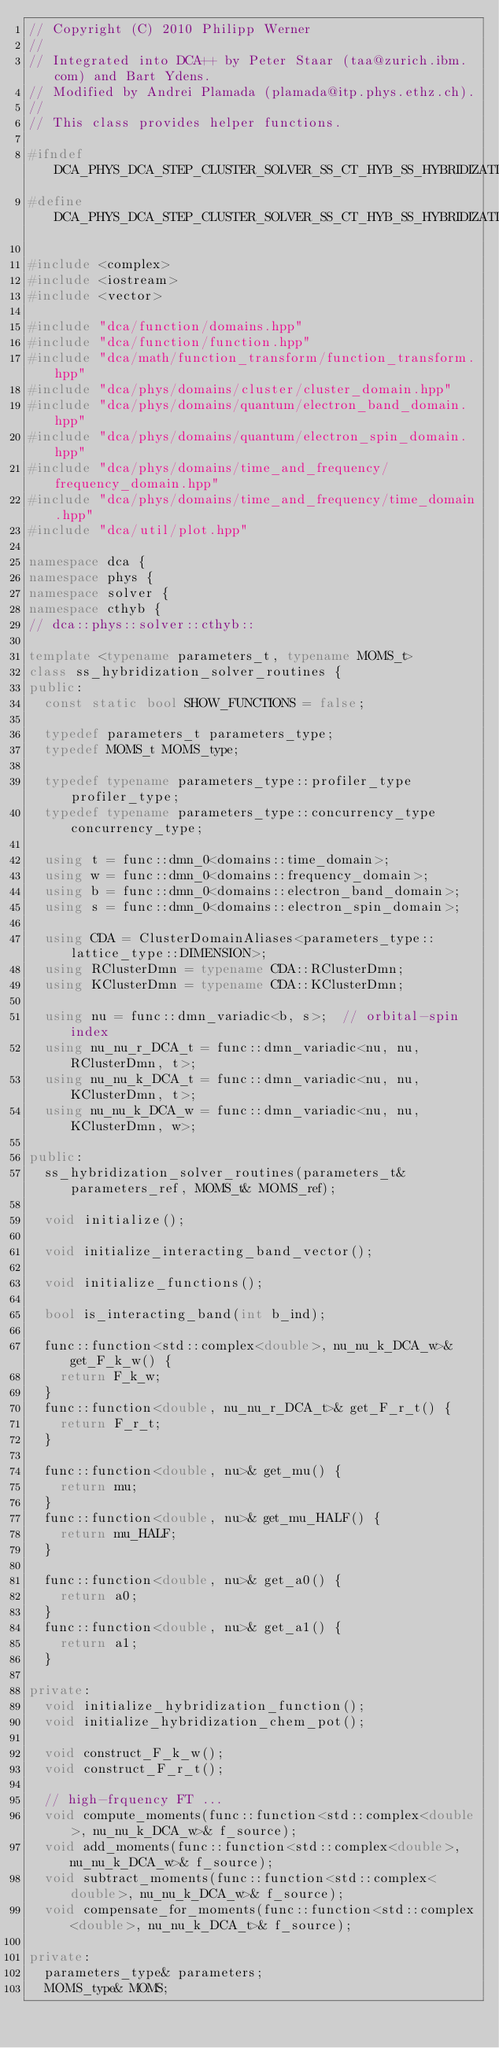<code> <loc_0><loc_0><loc_500><loc_500><_C++_>// Copyright (C) 2010 Philipp Werner
//
// Integrated into DCA++ by Peter Staar (taa@zurich.ibm.com) and Bart Ydens.
// Modified by Andrei Plamada (plamada@itp.phys.ethz.ch).
//
// This class provides helper functions.

#ifndef DCA_PHYS_DCA_STEP_CLUSTER_SOLVER_SS_CT_HYB_SS_HYBRIDIZATION_SOLVER_ROUTINES_HPP
#define DCA_PHYS_DCA_STEP_CLUSTER_SOLVER_SS_CT_HYB_SS_HYBRIDIZATION_SOLVER_ROUTINES_HPP

#include <complex>
#include <iostream>
#include <vector>

#include "dca/function/domains.hpp"
#include "dca/function/function.hpp"
#include "dca/math/function_transform/function_transform.hpp"
#include "dca/phys/domains/cluster/cluster_domain.hpp"
#include "dca/phys/domains/quantum/electron_band_domain.hpp"
#include "dca/phys/domains/quantum/electron_spin_domain.hpp"
#include "dca/phys/domains/time_and_frequency/frequency_domain.hpp"
#include "dca/phys/domains/time_and_frequency/time_domain.hpp"
#include "dca/util/plot.hpp"

namespace dca {
namespace phys {
namespace solver {
namespace cthyb {
// dca::phys::solver::cthyb::

template <typename parameters_t, typename MOMS_t>
class ss_hybridization_solver_routines {
public:
  const static bool SHOW_FUNCTIONS = false;

  typedef parameters_t parameters_type;
  typedef MOMS_t MOMS_type;

  typedef typename parameters_type::profiler_type profiler_type;
  typedef typename parameters_type::concurrency_type concurrency_type;

  using t = func::dmn_0<domains::time_domain>;
  using w = func::dmn_0<domains::frequency_domain>;
  using b = func::dmn_0<domains::electron_band_domain>;
  using s = func::dmn_0<domains::electron_spin_domain>;

  using CDA = ClusterDomainAliases<parameters_type::lattice_type::DIMENSION>;
  using RClusterDmn = typename CDA::RClusterDmn;
  using KClusterDmn = typename CDA::KClusterDmn;

  using nu = func::dmn_variadic<b, s>;  // orbital-spin index
  using nu_nu_r_DCA_t = func::dmn_variadic<nu, nu, RClusterDmn, t>;
  using nu_nu_k_DCA_t = func::dmn_variadic<nu, nu, KClusterDmn, t>;
  using nu_nu_k_DCA_w = func::dmn_variadic<nu, nu, KClusterDmn, w>;

public:
  ss_hybridization_solver_routines(parameters_t& parameters_ref, MOMS_t& MOMS_ref);

  void initialize();

  void initialize_interacting_band_vector();

  void initialize_functions();

  bool is_interacting_band(int b_ind);

  func::function<std::complex<double>, nu_nu_k_DCA_w>& get_F_k_w() {
    return F_k_w;
  }
  func::function<double, nu_nu_r_DCA_t>& get_F_r_t() {
    return F_r_t;
  }

  func::function<double, nu>& get_mu() {
    return mu;
  }
  func::function<double, nu>& get_mu_HALF() {
    return mu_HALF;
  }

  func::function<double, nu>& get_a0() {
    return a0;
  }
  func::function<double, nu>& get_a1() {
    return a1;
  }

private:
  void initialize_hybridization_function();
  void initialize_hybridization_chem_pot();

  void construct_F_k_w();
  void construct_F_r_t();

  // high-frquency FT ...
  void compute_moments(func::function<std::complex<double>, nu_nu_k_DCA_w>& f_source);
  void add_moments(func::function<std::complex<double>, nu_nu_k_DCA_w>& f_source);
  void subtract_moments(func::function<std::complex<double>, nu_nu_k_DCA_w>& f_source);
  void compensate_for_moments(func::function<std::complex<double>, nu_nu_k_DCA_t>& f_source);

private:
  parameters_type& parameters;
  MOMS_type& MOMS;</code> 